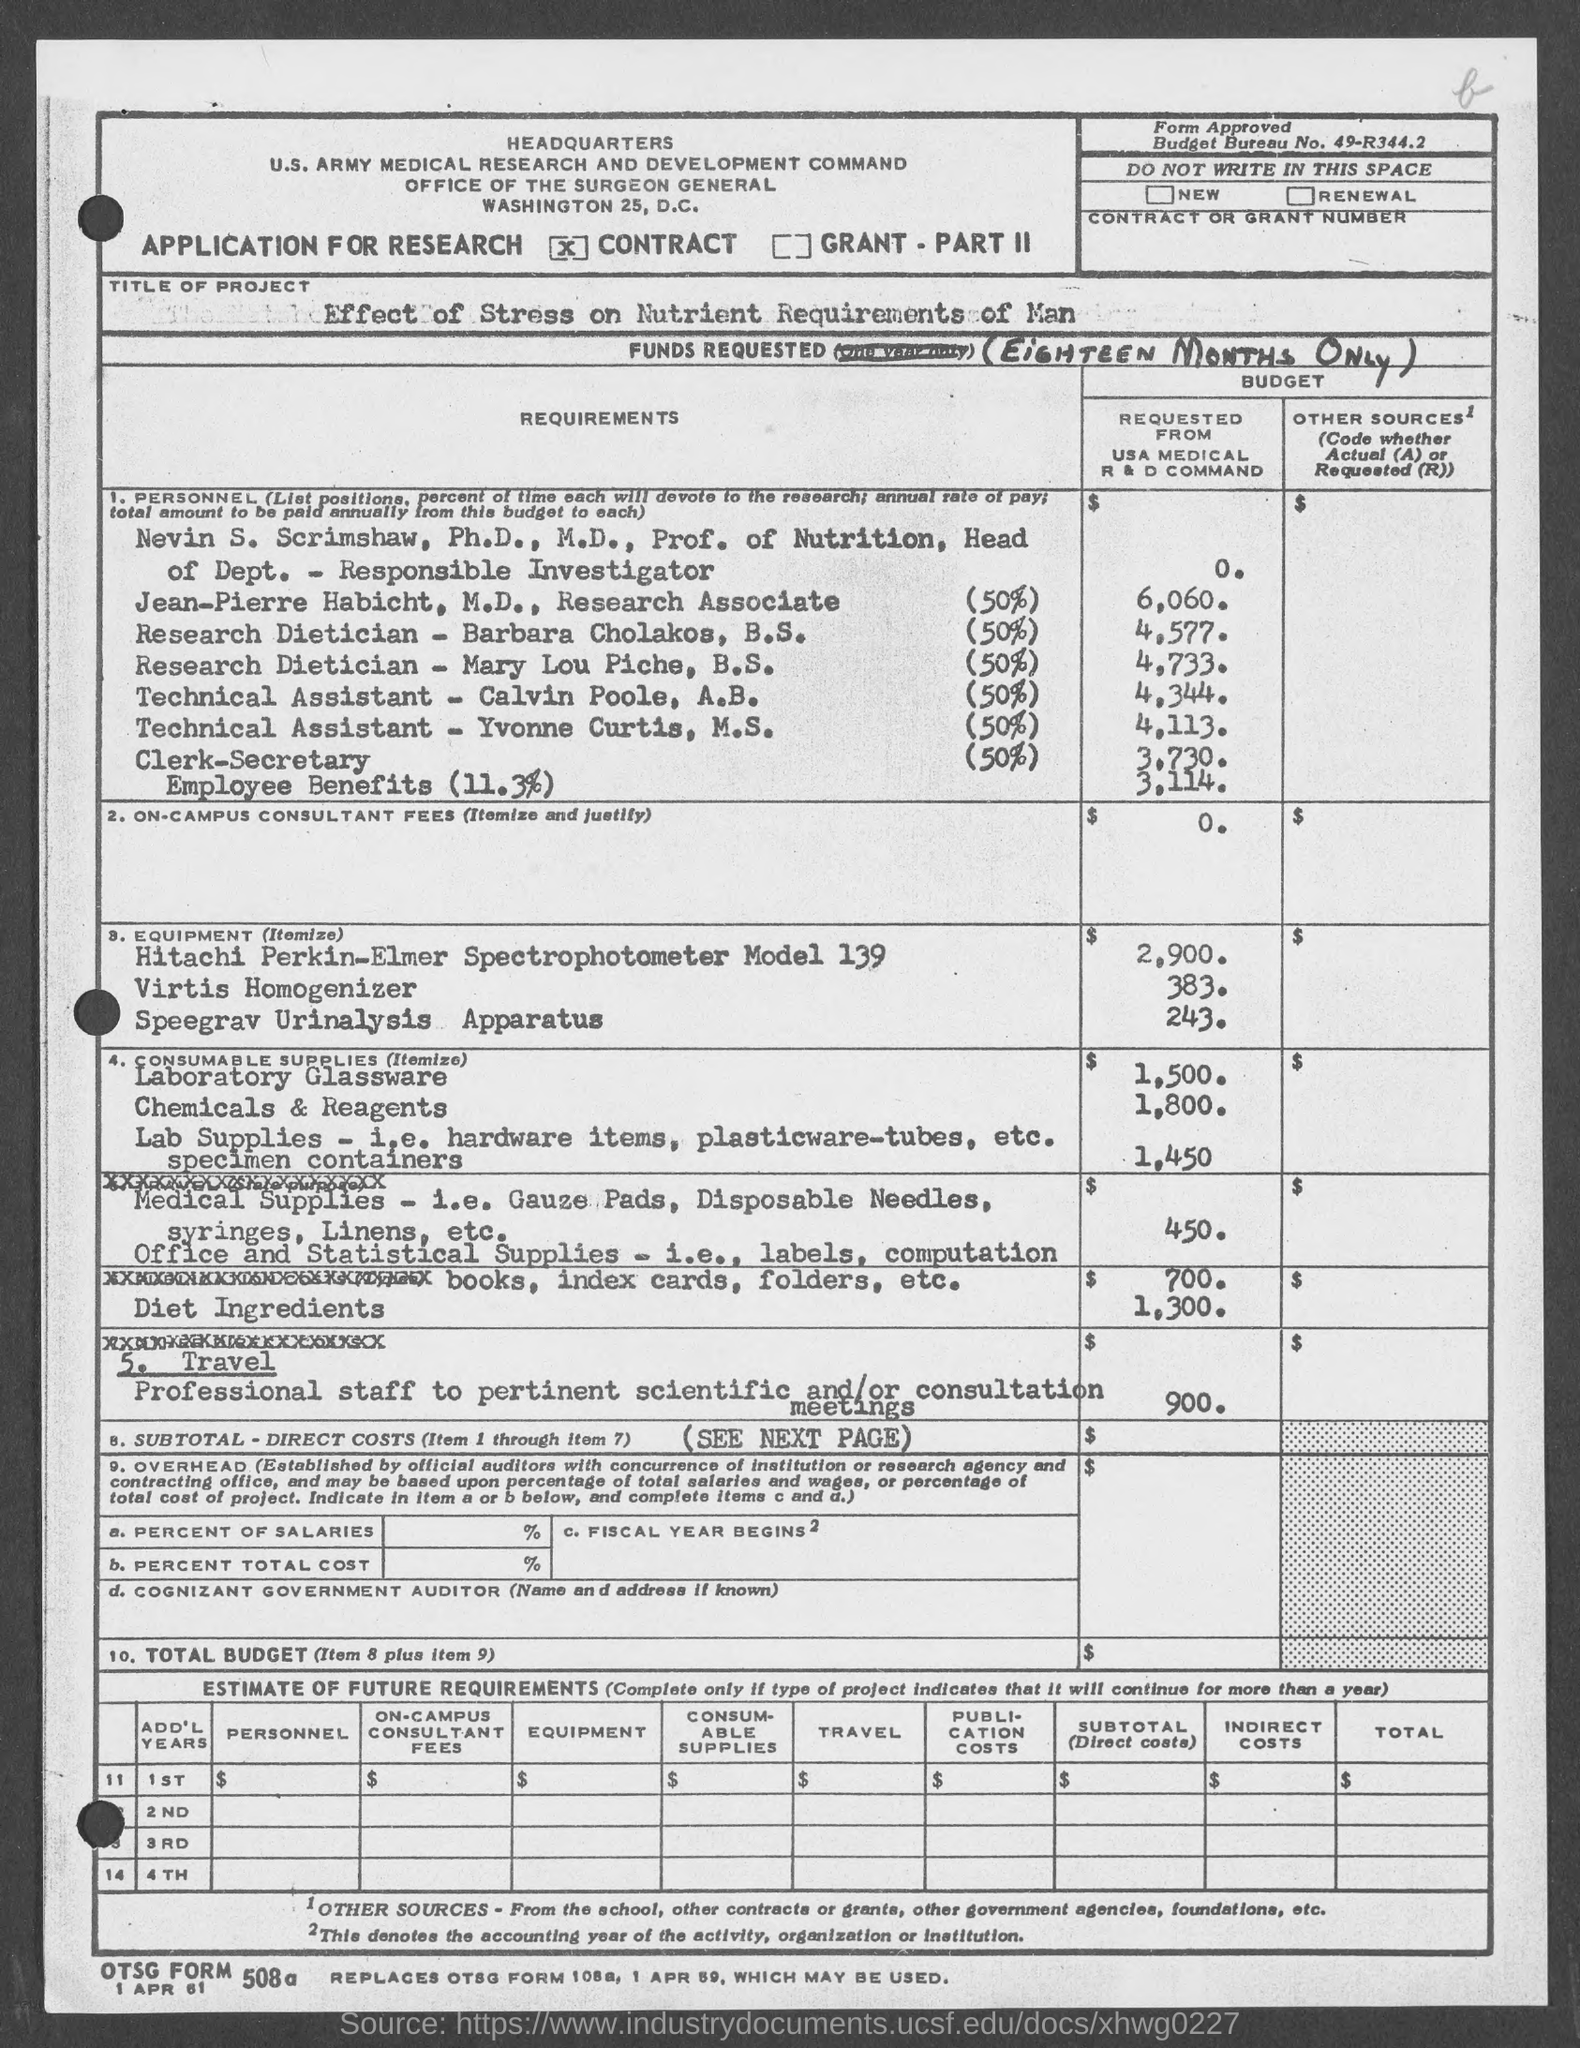What is the Title of the Project given in the application?
Offer a very short reply. Effect of Stress on Nutrient Requirements of Man. What is the Budget Bureau No. given in the application?
Your answer should be very brief. 49-R344.2. 